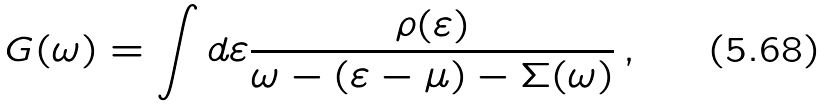Convert formula to latex. <formula><loc_0><loc_0><loc_500><loc_500>G ( \omega ) = \int d \varepsilon \frac { \rho ( \varepsilon ) } { \omega - ( \varepsilon - \mu ) - \Sigma ( \omega ) } \, ,</formula> 